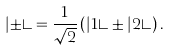Convert formula to latex. <formula><loc_0><loc_0><loc_500><loc_500>| \pm \rangle = \frac { 1 } { \sqrt { 2 } } \left ( | 1 \rangle \pm | 2 \rangle \right ) .</formula> 